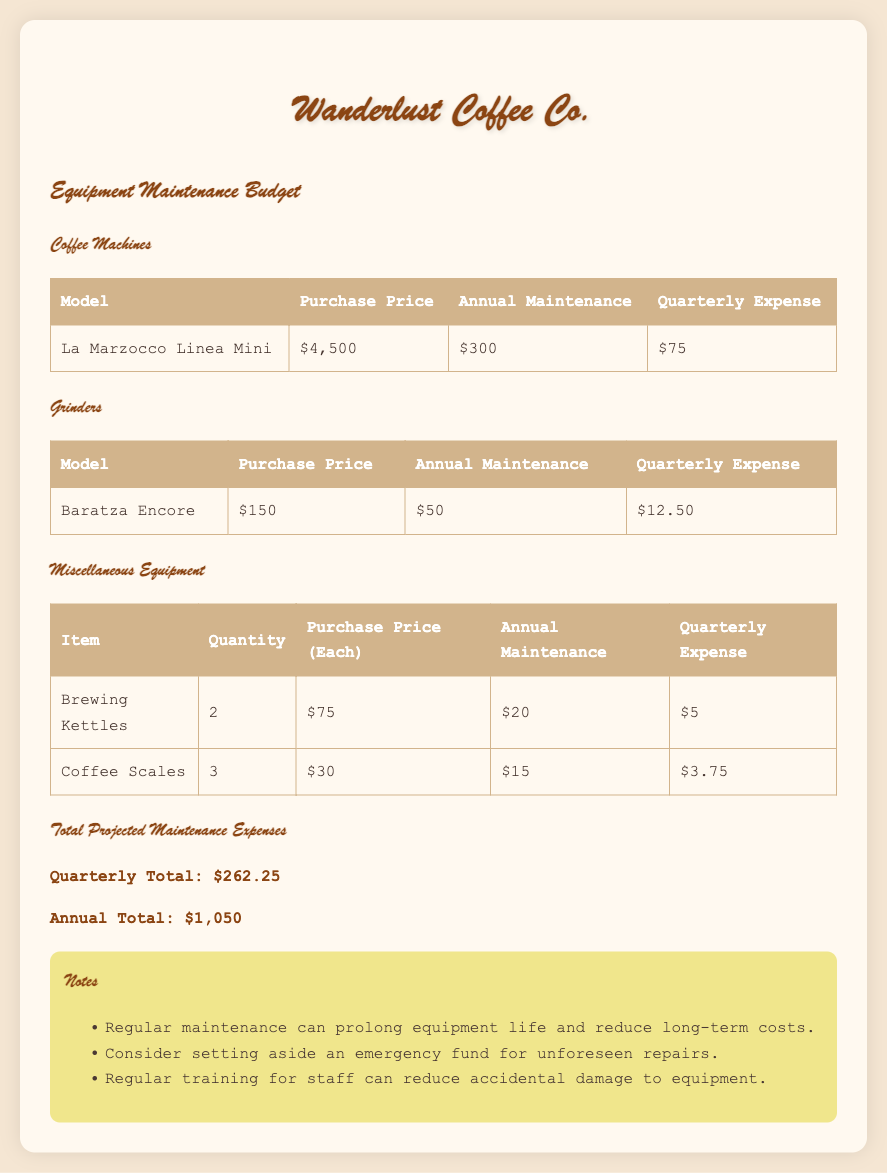what is the purchase price of the La Marzocco Linea Mini? The purchase price for the La Marzocco Linea Mini is listed in the Coffee Machines section as $4,500.
Answer: $4,500 what is the quarterly expense for the Baratza Encore grinder? The quarterly expense for the Baratza Encore can be found in the Grinders section, which states it is $12.50.
Answer: $12.50 how many Brewing Kettles are listed in the budget? The table for Miscellaneous Equipment shows that there are 2 Brewing Kettles listed.
Answer: 2 what is the total projected quarterly maintenance expenses? The total projected maintenance expenses are summarized at the end of the document, showing a quarterly total of $262.25.
Answer: $262.25 what is the annual maintenance cost for all equipment combined? The document states the annual total for equipment maintenance expenses is $1,050.
Answer: $1,050 what is the annual maintenance cost for the La Marzocco Linea Mini? The maintenance details in the Coffee Machines section indicate that the annual maintenance for the La Marzocco Linea Mini is $300.
Answer: $300 what is the total number of Coffee Scales mentioned in the budget? The Miscellaneous Equipment section provides that there are 3 Coffee Scales included in the listing.
Answer: 3 what is suggested to consider for unforeseen repairs? A note suggests considering setting aside an emergency fund for unforeseen repairs.
Answer: emergency fund 